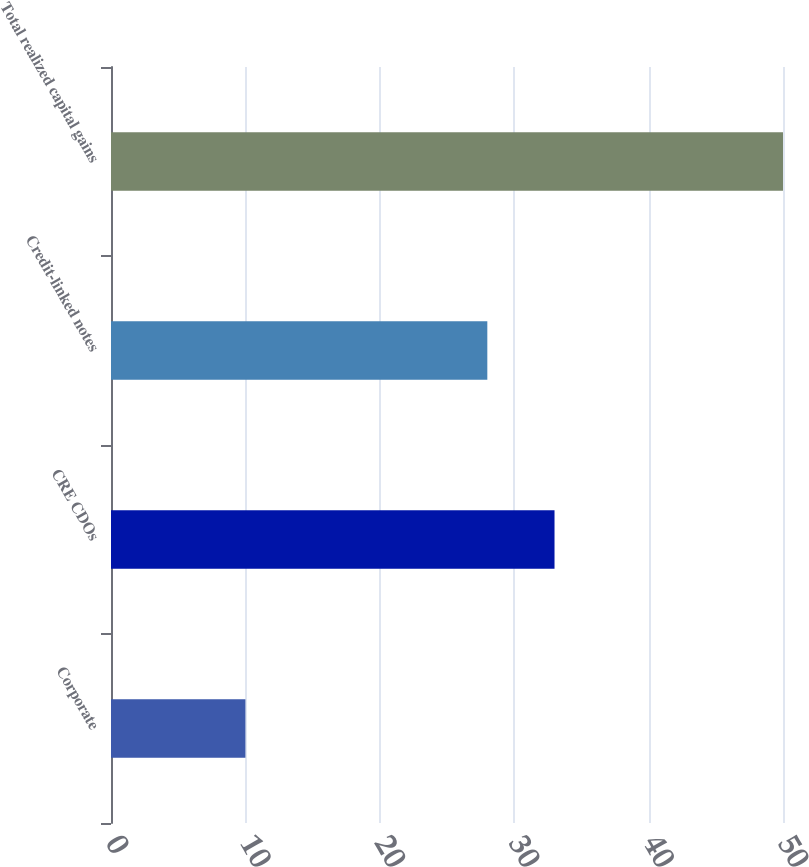Convert chart. <chart><loc_0><loc_0><loc_500><loc_500><bar_chart><fcel>Corporate<fcel>CRE CDOs<fcel>Credit-linked notes<fcel>Total realized capital gains<nl><fcel>10<fcel>33<fcel>28<fcel>50<nl></chart> 